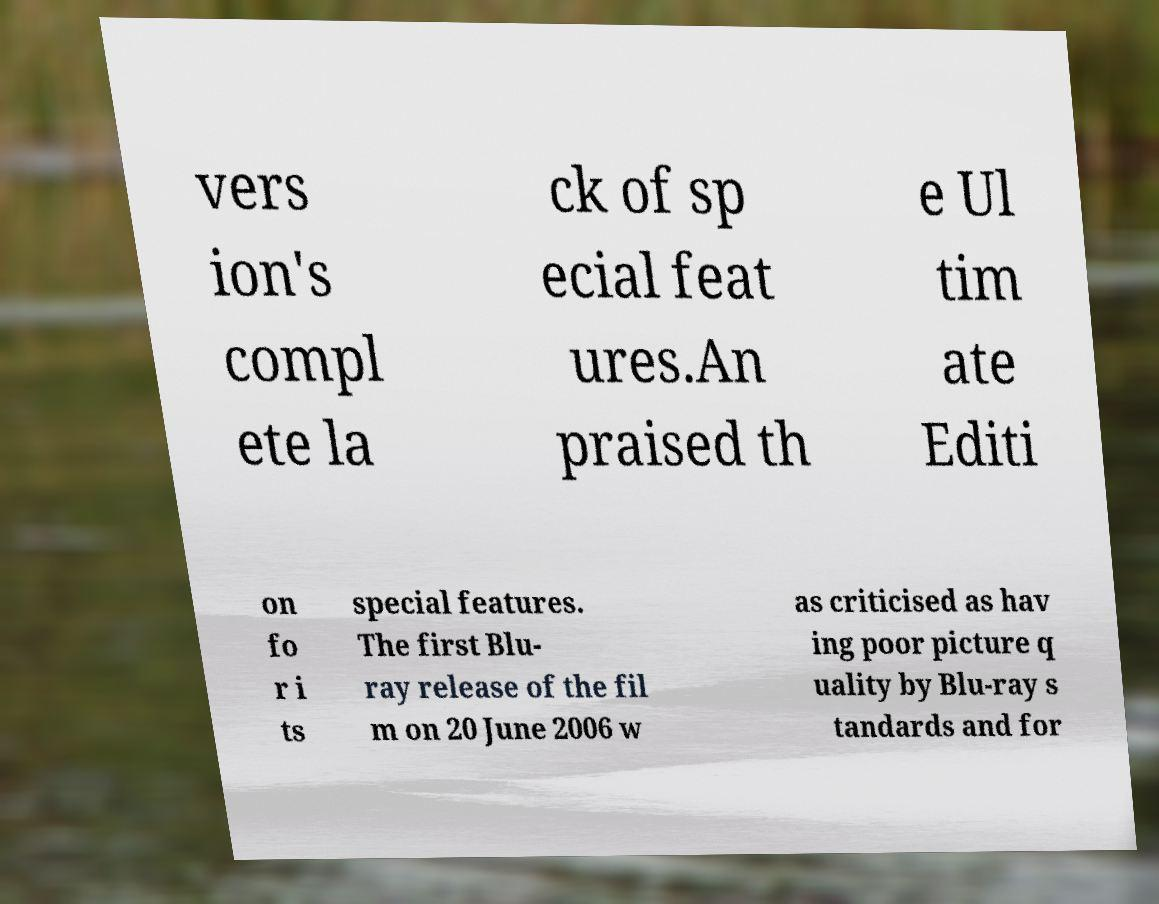What messages or text are displayed in this image? I need them in a readable, typed format. vers ion's compl ete la ck of sp ecial feat ures.An praised th e Ul tim ate Editi on fo r i ts special features. The first Blu- ray release of the fil m on 20 June 2006 w as criticised as hav ing poor picture q uality by Blu-ray s tandards and for 